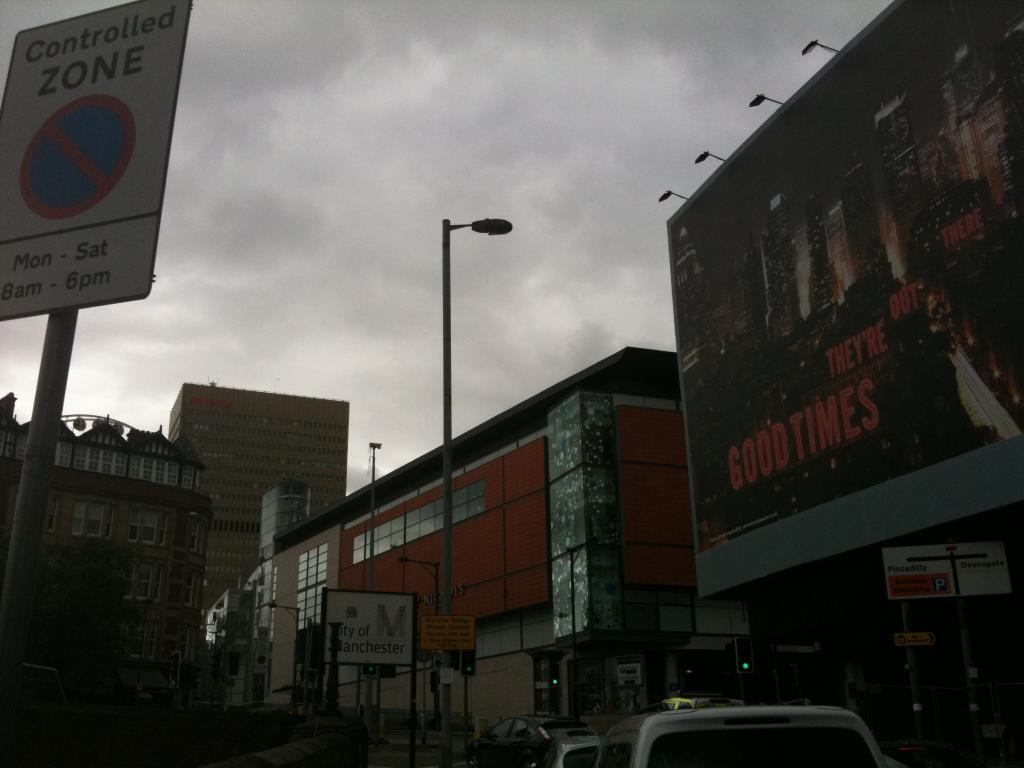What types of objects can be seen in the image? There are vehicles, boards, lights on poles, a hoarding, and buildings in the image. Can you describe the lighting in the image? There are lights on poles and lights above the hoarding in the image. What is visible in the background of the image? The sky is visible in the image, and clouds are present in the sky. How far away is the school from the image? There is no school present in the image, so it is not possible to determine the distance to one. What type of bomb can be seen in the image? There is no bomb present in the image. 